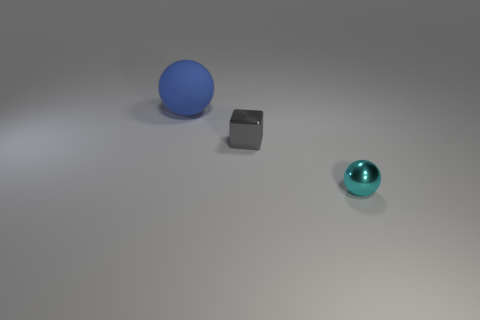Add 2 gray metal blocks. How many objects exist? 5 Subtract all blocks. How many objects are left? 2 Add 3 blue rubber things. How many blue rubber things exist? 4 Subtract 0 gray balls. How many objects are left? 3 Subtract all large shiny balls. Subtract all tiny cyan spheres. How many objects are left? 2 Add 1 metal things. How many metal things are left? 3 